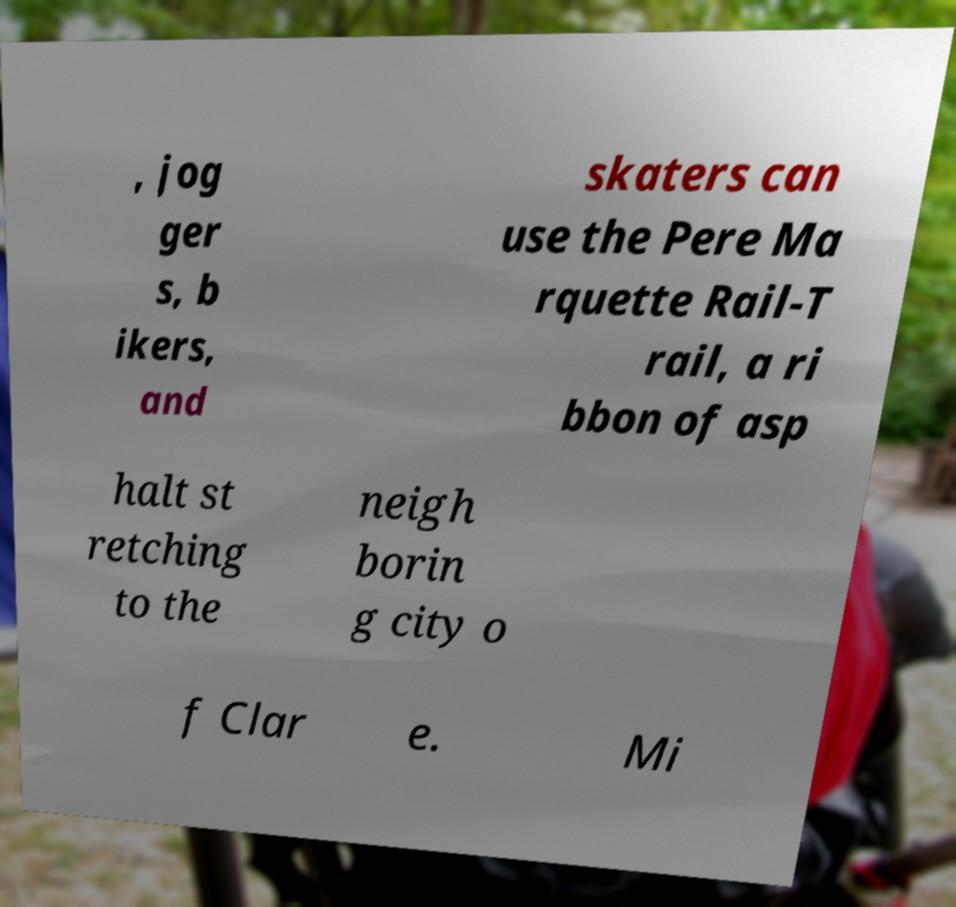Can you read and provide the text displayed in the image?This photo seems to have some interesting text. Can you extract and type it out for me? , jog ger s, b ikers, and skaters can use the Pere Ma rquette Rail-T rail, a ri bbon of asp halt st retching to the neigh borin g city o f Clar e. Mi 